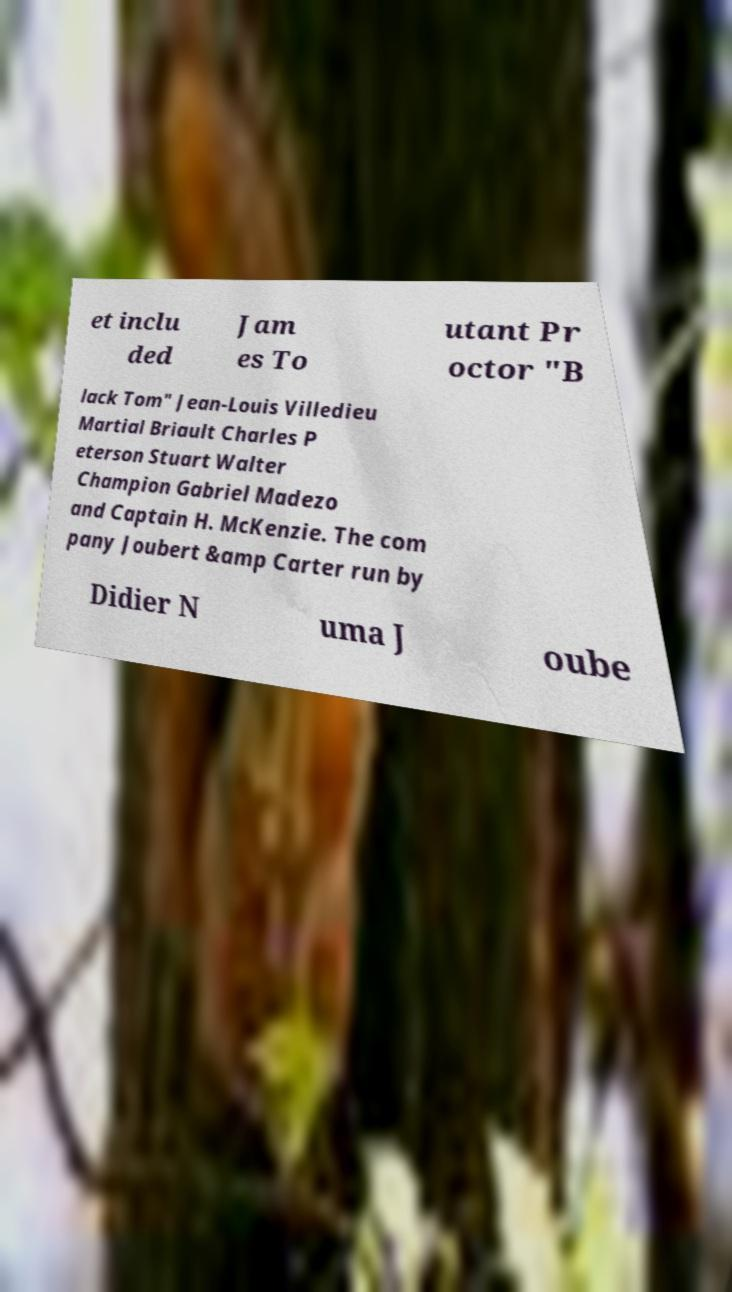Could you assist in decoding the text presented in this image and type it out clearly? et inclu ded Jam es To utant Pr octor "B lack Tom" Jean-Louis Villedieu Martial Briault Charles P eterson Stuart Walter Champion Gabriel Madezo and Captain H. McKenzie. The com pany Joubert &amp Carter run by Didier N uma J oube 